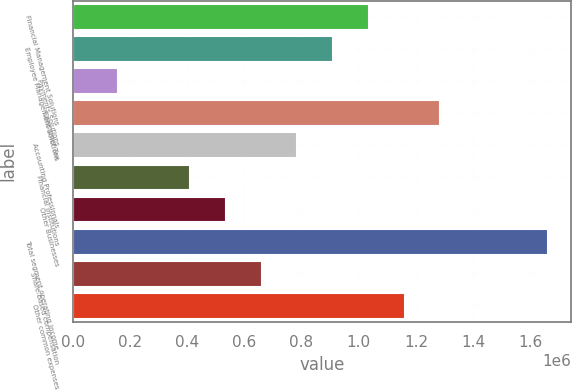Convert chart to OTSL. <chart><loc_0><loc_0><loc_500><loc_500><bar_chart><fcel>Financial Management Solutions<fcel>Employee Management Solutions<fcel>Payments Solutions<fcel>Consumer Tax<fcel>Accounting Professionals<fcel>Financial Institutions<fcel>Other Businesses<fcel>Total segment operating income<fcel>Share-based compensation<fcel>Other common expenses<nl><fcel>1.03531e+06<fcel>910332<fcel>160492<fcel>1.28525e+06<fcel>785359<fcel>410438<fcel>535412<fcel>1.66017e+06<fcel>660386<fcel>1.16028e+06<nl></chart> 